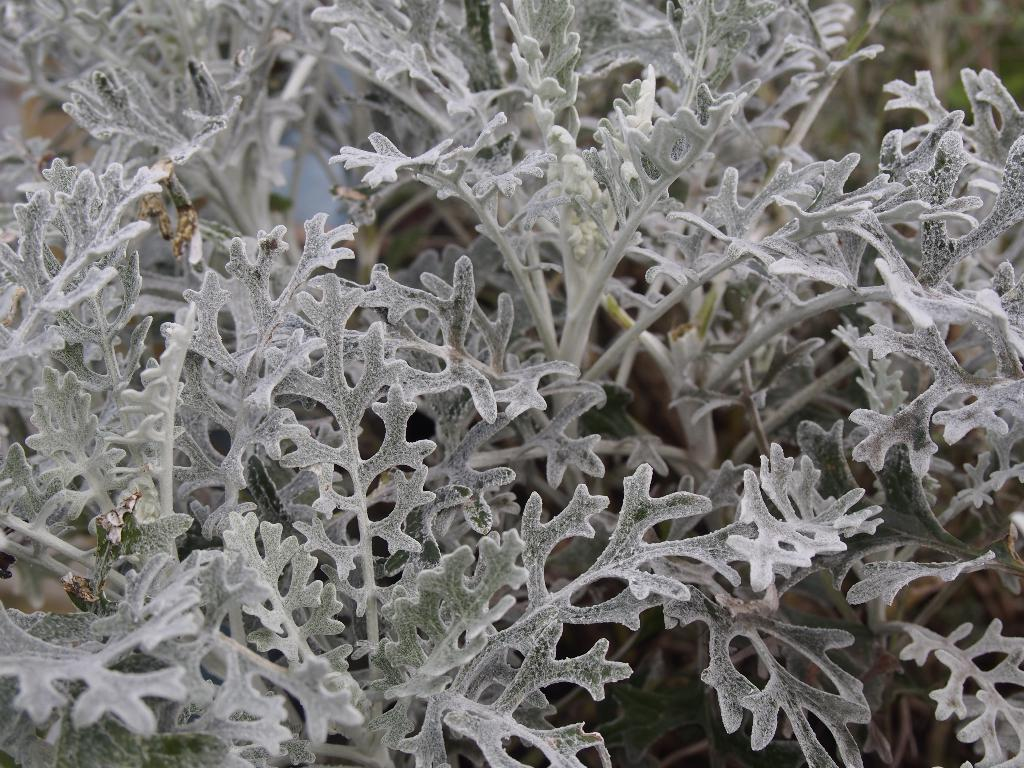What type of vegetation can be seen in the image? There are leaves in the image. Can you describe any part of the plant that is visible? The stem of a plant is visible in the image. What type of powder is being used by the writer in the image? There is no writer or powder present in the image; it only features leaves and a plant stem. 